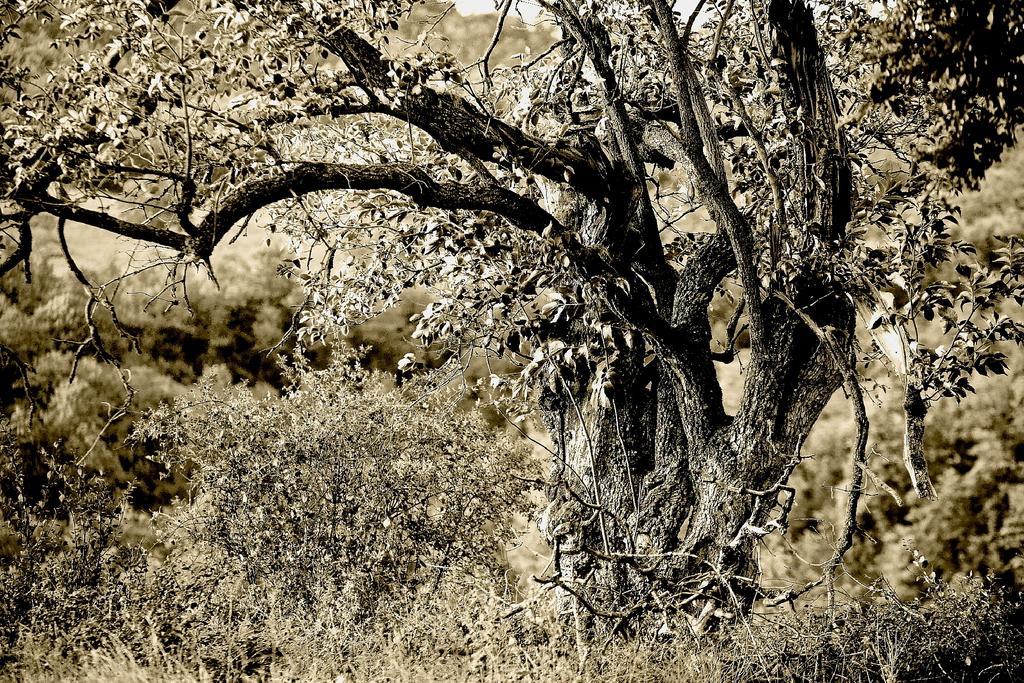Can you describe this image briefly? In this picture I can see few trees and plant and I see that this is an edited picture. 